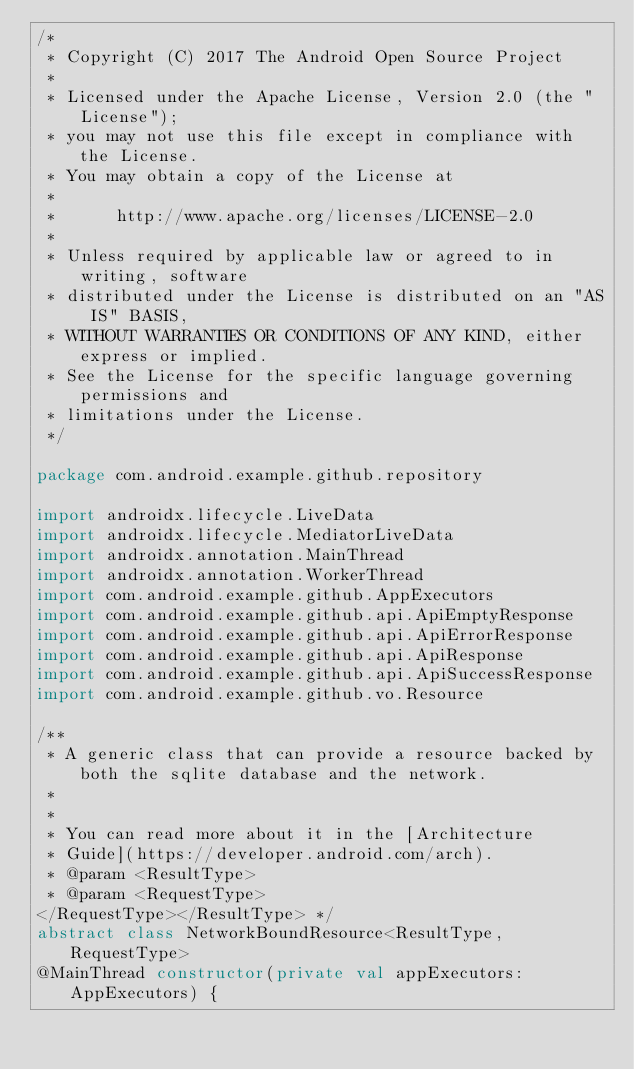Convert code to text. <code><loc_0><loc_0><loc_500><loc_500><_Kotlin_>/*
 * Copyright (C) 2017 The Android Open Source Project
 *
 * Licensed under the Apache License, Version 2.0 (the "License");
 * you may not use this file except in compliance with the License.
 * You may obtain a copy of the License at
 *
 *      http://www.apache.org/licenses/LICENSE-2.0
 *
 * Unless required by applicable law or agreed to in writing, software
 * distributed under the License is distributed on an "AS IS" BASIS,
 * WITHOUT WARRANTIES OR CONDITIONS OF ANY KIND, either express or implied.
 * See the License for the specific language governing permissions and
 * limitations under the License.
 */

package com.android.example.github.repository

import androidx.lifecycle.LiveData
import androidx.lifecycle.MediatorLiveData
import androidx.annotation.MainThread
import androidx.annotation.WorkerThread
import com.android.example.github.AppExecutors
import com.android.example.github.api.ApiEmptyResponse
import com.android.example.github.api.ApiErrorResponse
import com.android.example.github.api.ApiResponse
import com.android.example.github.api.ApiSuccessResponse
import com.android.example.github.vo.Resource

/**
 * A generic class that can provide a resource backed by both the sqlite database and the network.
 *
 *
 * You can read more about it in the [Architecture
 * Guide](https://developer.android.com/arch).
 * @param <ResultType>
 * @param <RequestType>
</RequestType></ResultType> */
abstract class NetworkBoundResource<ResultType, RequestType>
@MainThread constructor(private val appExecutors: AppExecutors) {
</code> 